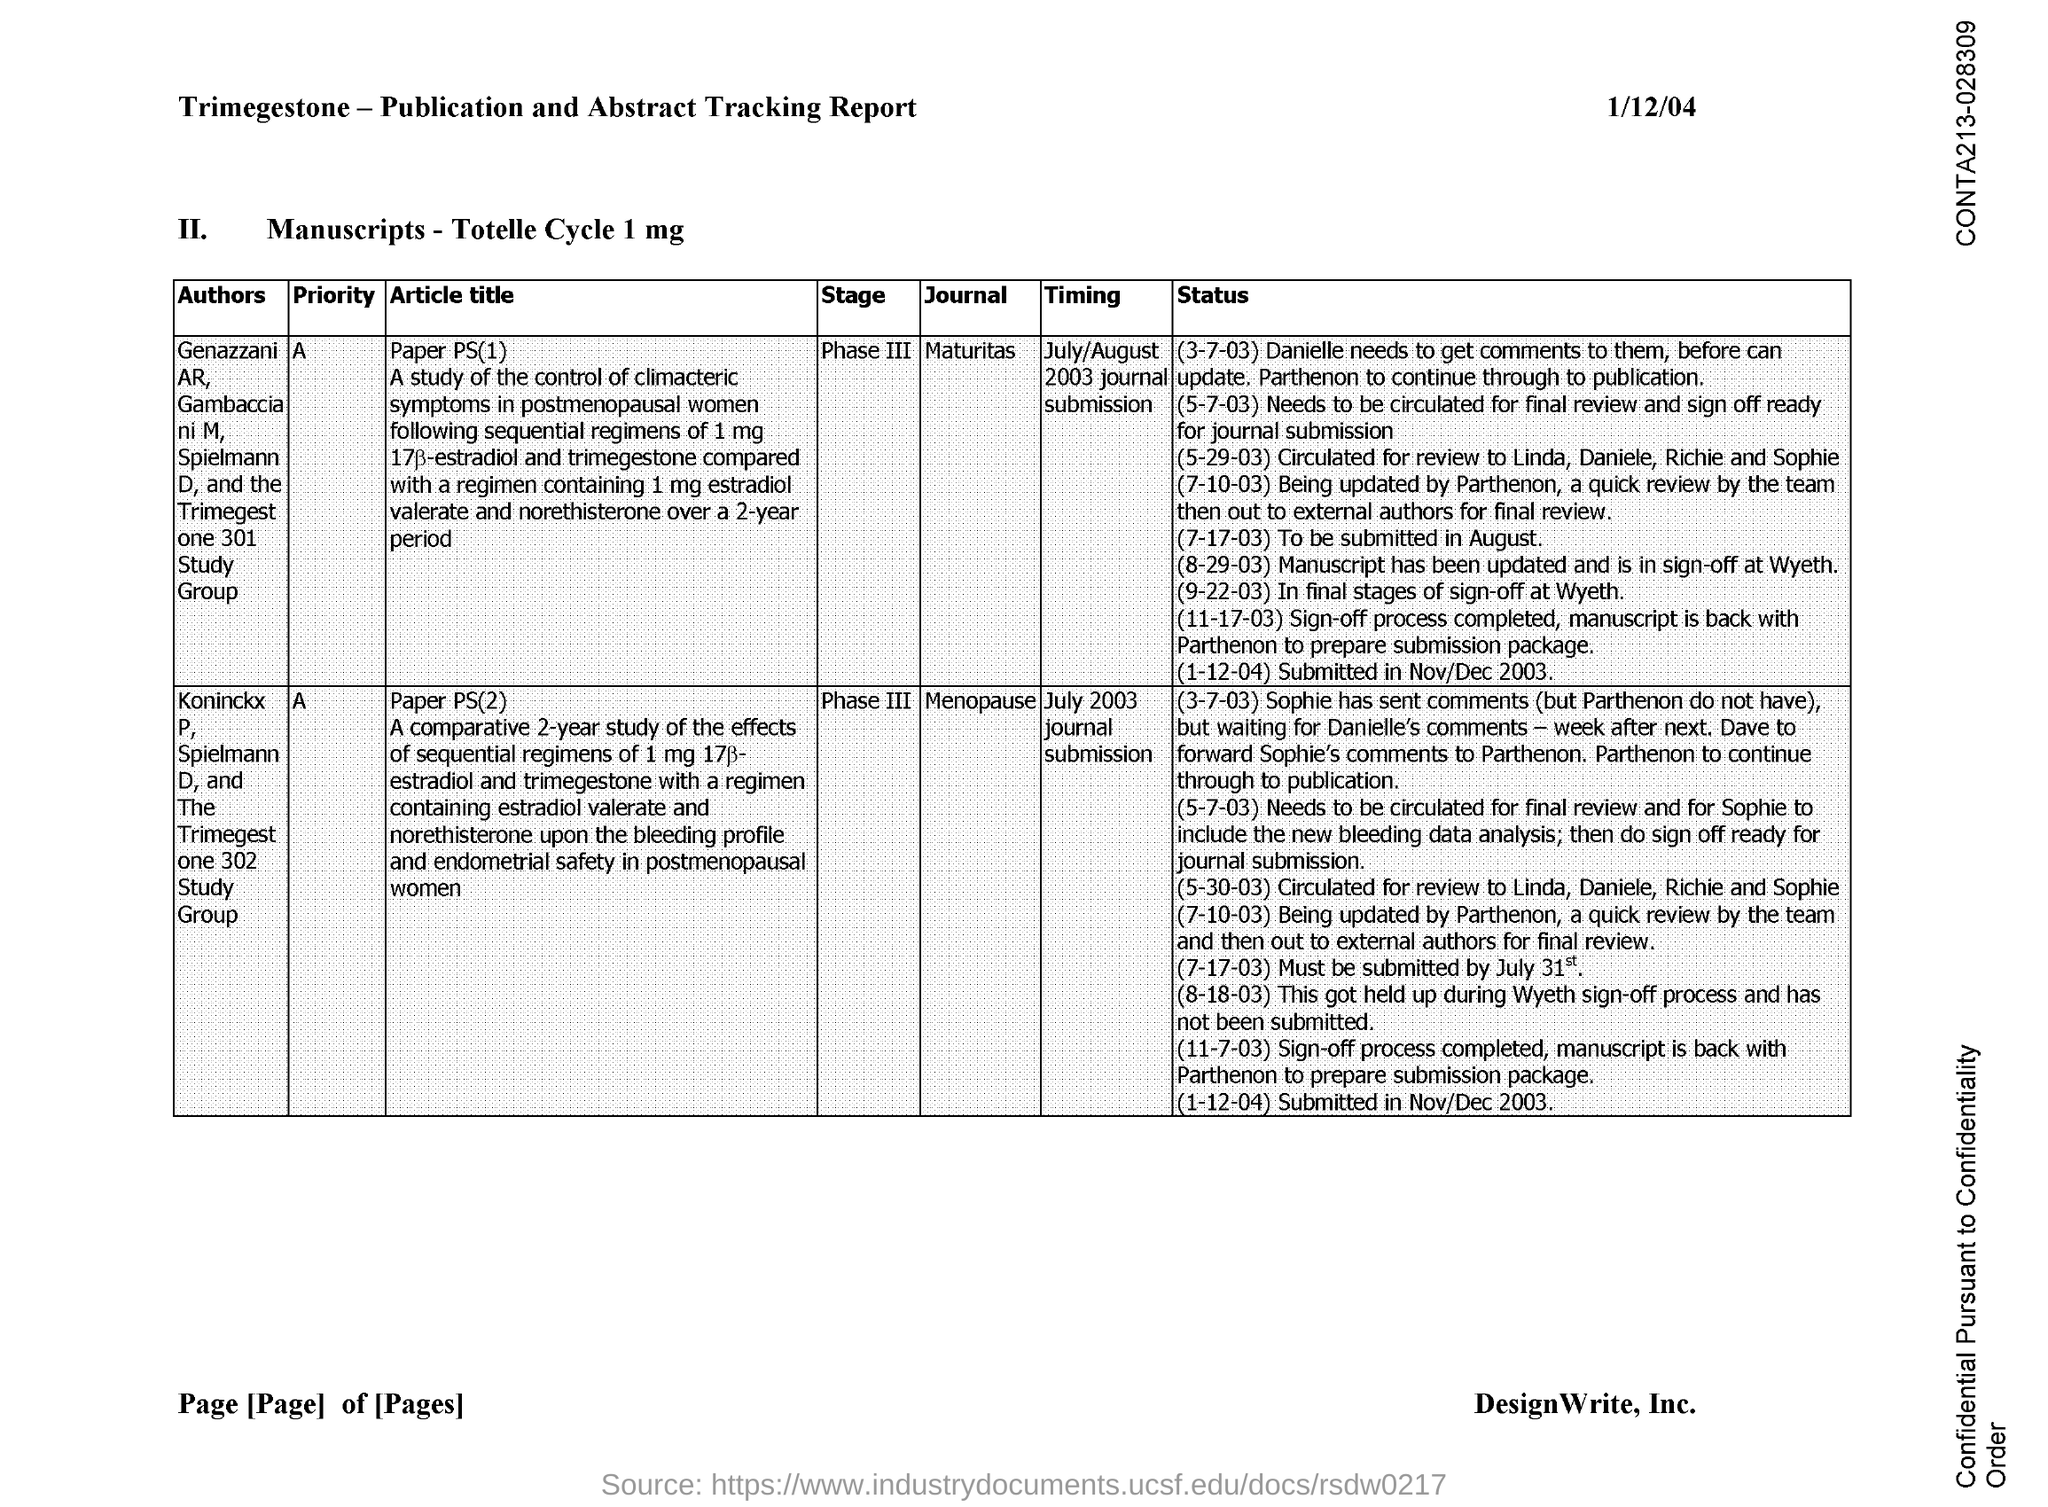What is the first title in the document?
Provide a succinct answer. Trimegestone-Publication and Abstract Tracking Report. What is the priority of the journal "Maturitas"?
Provide a short and direct response. A. What is the priority of the journal "Menopause"?
Offer a very short reply. A. 